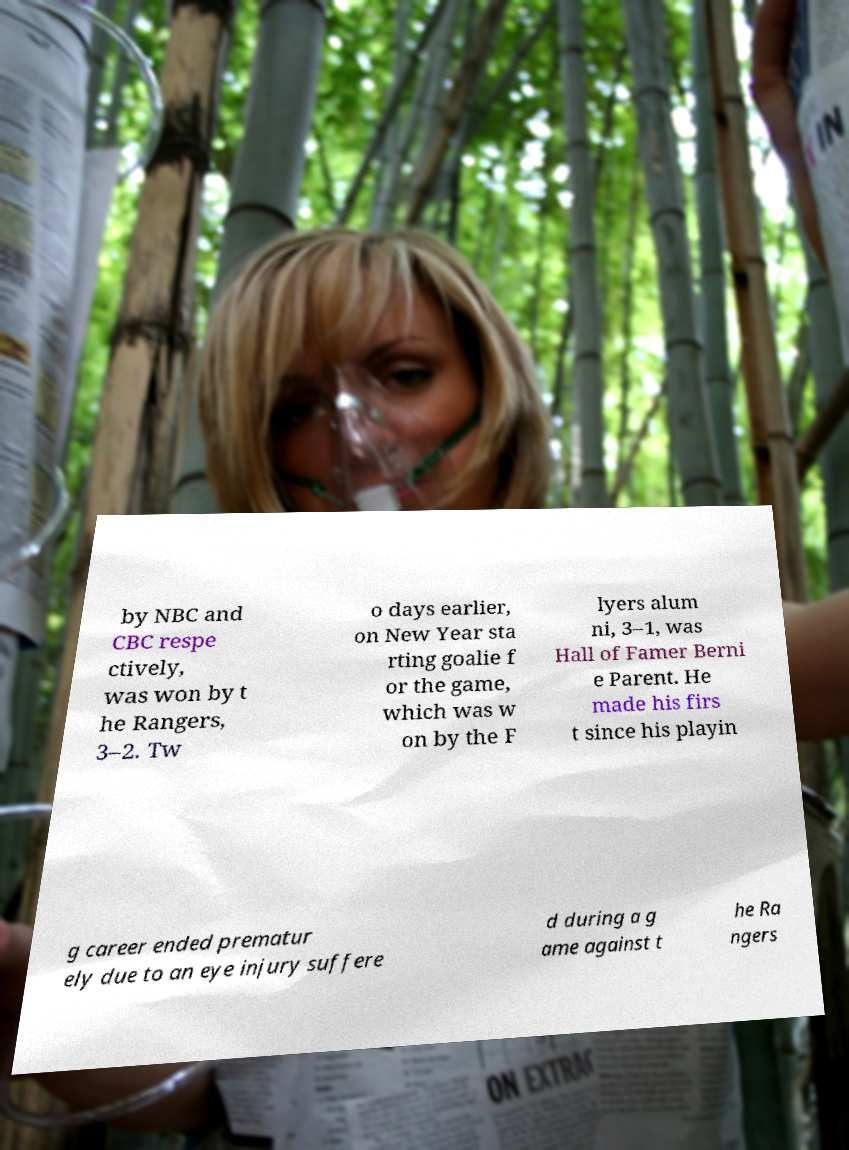I need the written content from this picture converted into text. Can you do that? by NBC and CBC respe ctively, was won by t he Rangers, 3–2. Tw o days earlier, on New Year sta rting goalie f or the game, which was w on by the F lyers alum ni, 3–1, was Hall of Famer Berni e Parent. He made his firs t since his playin g career ended prematur ely due to an eye injury suffere d during a g ame against t he Ra ngers 